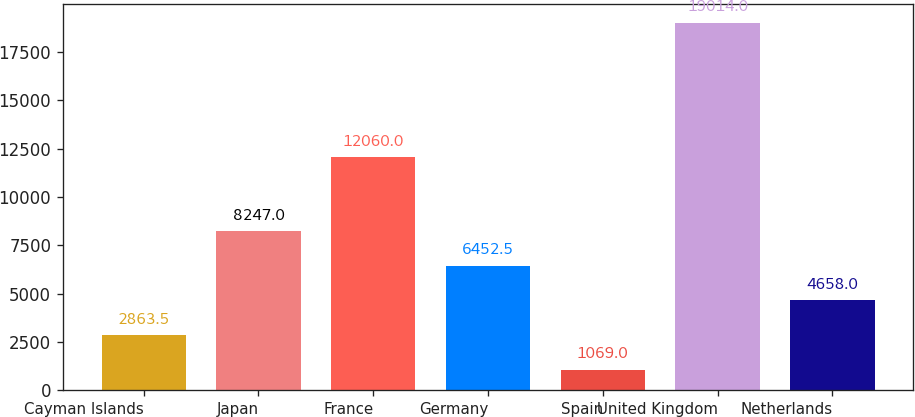Convert chart. <chart><loc_0><loc_0><loc_500><loc_500><bar_chart><fcel>Cayman Islands<fcel>Japan<fcel>France<fcel>Germany<fcel>Spain<fcel>United Kingdom<fcel>Netherlands<nl><fcel>2863.5<fcel>8247<fcel>12060<fcel>6452.5<fcel>1069<fcel>19014<fcel>4658<nl></chart> 